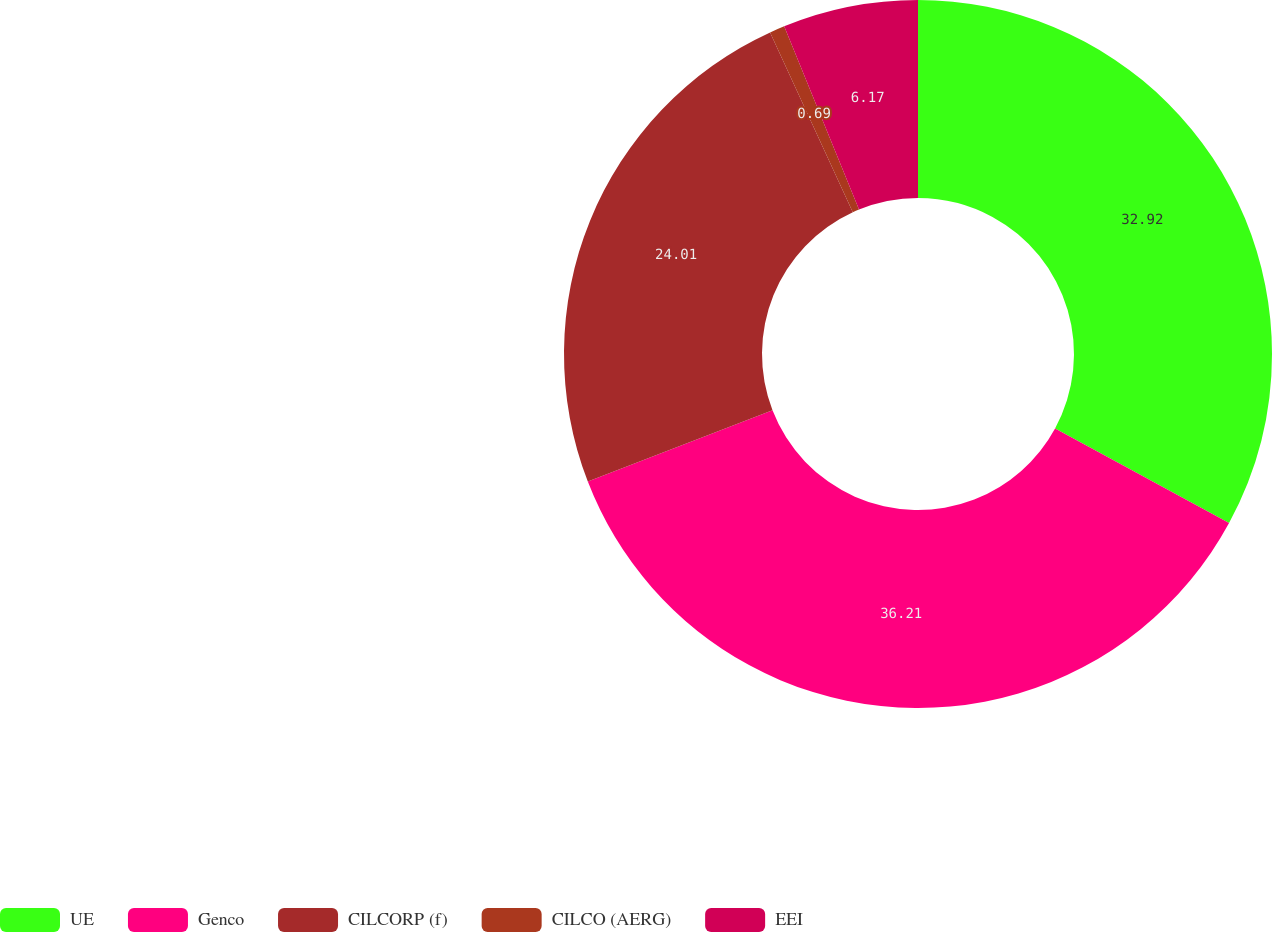Convert chart to OTSL. <chart><loc_0><loc_0><loc_500><loc_500><pie_chart><fcel>UE<fcel>Genco<fcel>CILCORP (f)<fcel>CILCO (AERG)<fcel>EEI<nl><fcel>32.92%<fcel>36.21%<fcel>24.01%<fcel>0.69%<fcel>6.17%<nl></chart> 